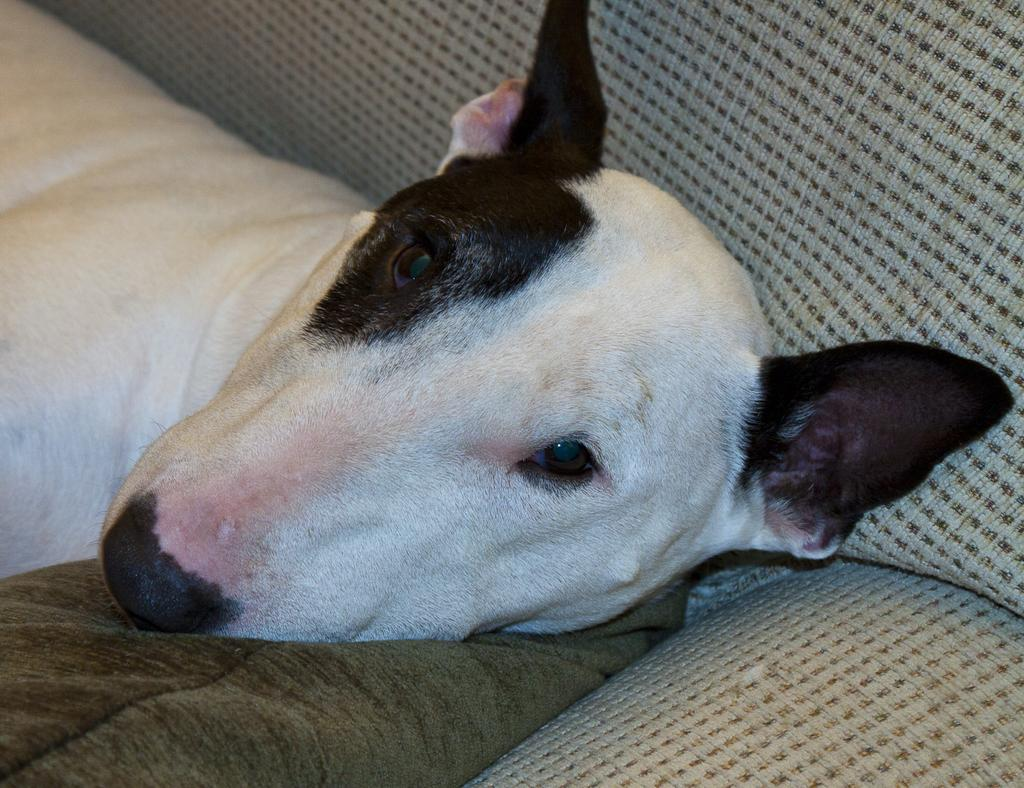What type of animal is in the image? There is a dog in the image. What is the dog doing in the image? The dog is laying on a couch. What type of yam is the dog using as a pillow in the image? There is no yam present in the image, and the dog is not using any object as a pillow. 